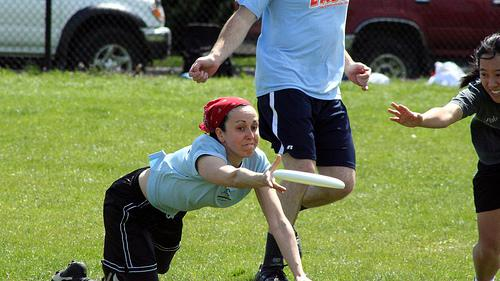Question: what game is being played?
Choices:
A. Tennis.
B. Frisbee.
C. Golf.
D. Bowling.
Answer with the letter. Answer: B Question: what color is the grass?
Choices:
A. Green.
B. Brown.
C. Yellow.
D. Yellowish-brown.
Answer with the letter. Answer: A Question: how many vehicles are shown?
Choices:
A. Ten.
B. Two.
C. Twenty.
D. Thirty.
Answer with the letter. Answer: B Question: where are the vehicles?
Choices:
A. Parking garage.
B. Background.
C. Airport Tarmac.
D. Underwater.
Answer with the letter. Answer: B Question: what color is the shirt of the person on the far right?
Choices:
A. Red.
B. Blue.
C. White.
D. Black.
Answer with the letter. Answer: D 